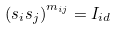Convert formula to latex. <formula><loc_0><loc_0><loc_500><loc_500>\left ( s _ { i } s _ { j } \right ) ^ { m _ { i j } } = I _ { i d }</formula> 